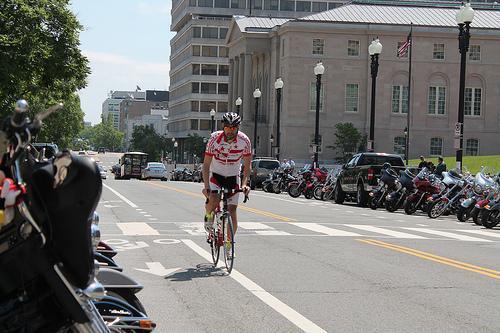How many people are riding on bicycle?
Give a very brief answer. 1. 